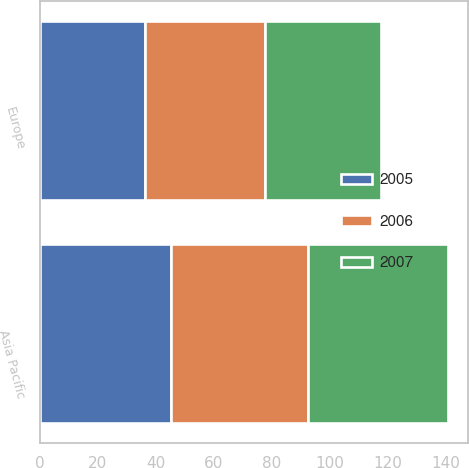Convert chart. <chart><loc_0><loc_0><loc_500><loc_500><stacked_bar_chart><ecel><fcel>Europe<fcel>Asia Pacific<nl><fcel>2007<fcel>40<fcel>48.2<nl><fcel>2006<fcel>41.4<fcel>47.5<nl><fcel>2005<fcel>36.3<fcel>45.2<nl></chart> 